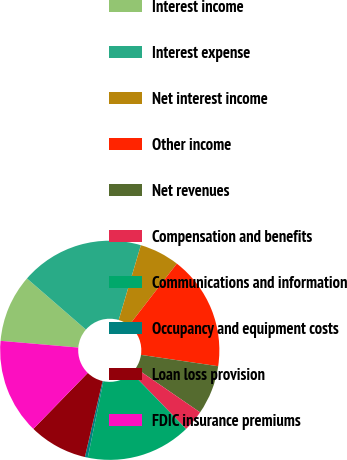Convert chart to OTSL. <chart><loc_0><loc_0><loc_500><loc_500><pie_chart><fcel>Interest income<fcel>Interest expense<fcel>Net interest income<fcel>Other income<fcel>Net revenues<fcel>Compensation and benefits<fcel>Communications and information<fcel>Occupancy and equipment costs<fcel>Loan loss provision<fcel>FDIC insurance premiums<nl><fcel>10.0%<fcel>18.21%<fcel>5.9%<fcel>16.84%<fcel>7.26%<fcel>3.16%<fcel>15.47%<fcel>0.43%<fcel>8.63%<fcel>14.1%<nl></chart> 